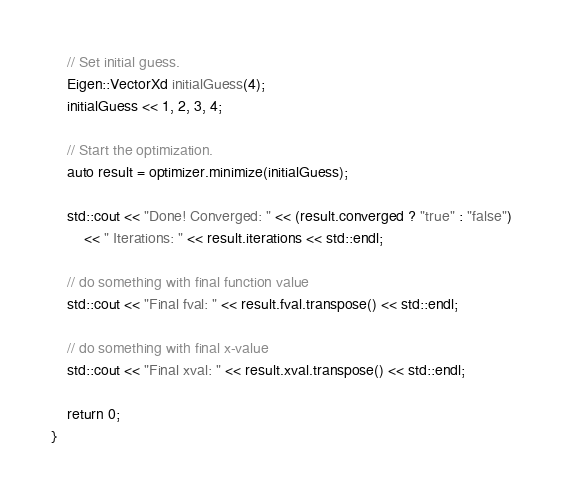<code> <loc_0><loc_0><loc_500><loc_500><_C++_>    // Set initial guess.
    Eigen::VectorXd initialGuess(4);
    initialGuess << 1, 2, 3, 4;

    // Start the optimization.
    auto result = optimizer.minimize(initialGuess);

    std::cout << "Done! Converged: " << (result.converged ? "true" : "false")
        << " Iterations: " << result.iterations << std::endl;

    // do something with final function value
    std::cout << "Final fval: " << result.fval.transpose() << std::endl;

    // do something with final x-value
    std::cout << "Final xval: " << result.xval.transpose() << std::endl;

    return 0;
}
</code> 